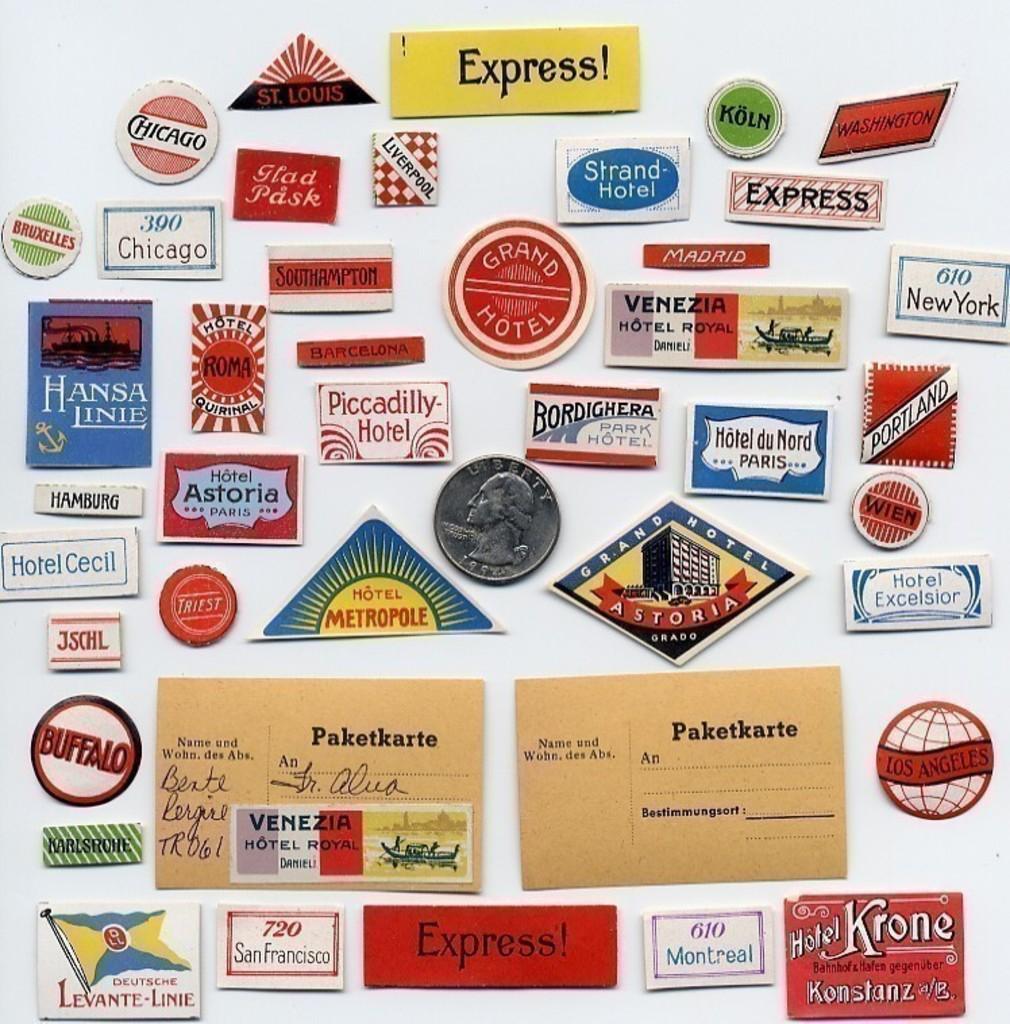What us state is mentioned in the upper right hand corner?
Offer a terse response. Washington. What word is written with an exclamation point at the top?
Your answer should be very brief. Express. 